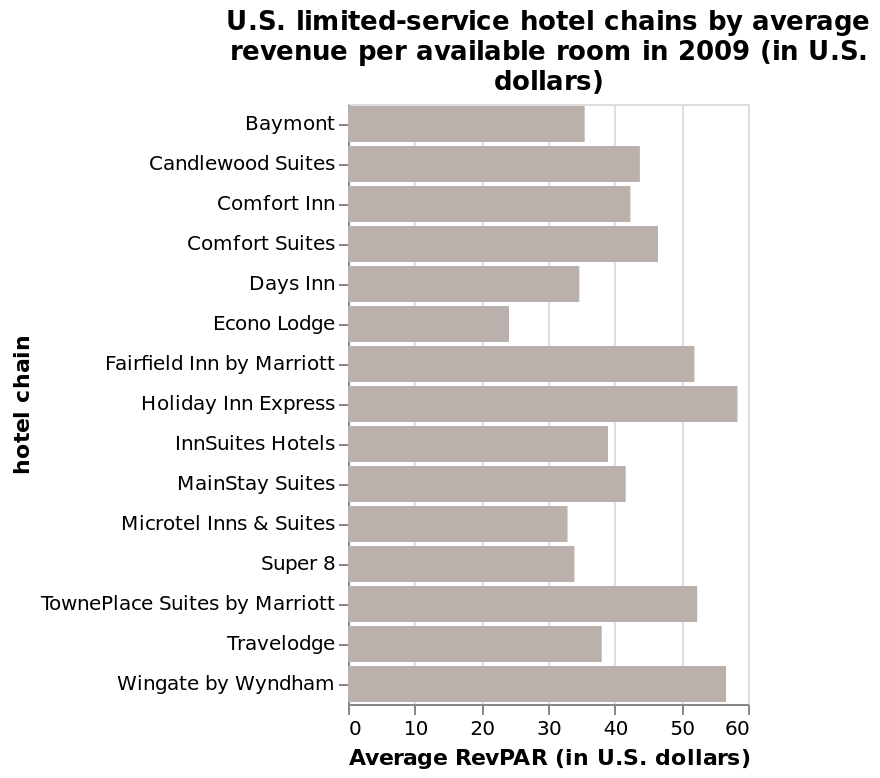<image>
Which hotel chain recorded the lowest average revenue per available room in 2009?  Econdo Lodge hotel chain recorded the lowest average revenue per available room in 2009. What is the name of the bar plot?  The name of the bar plot is "U.S. limited-service hotel chains by average revenue per available room in 2009 (in U.S. dollars)." 